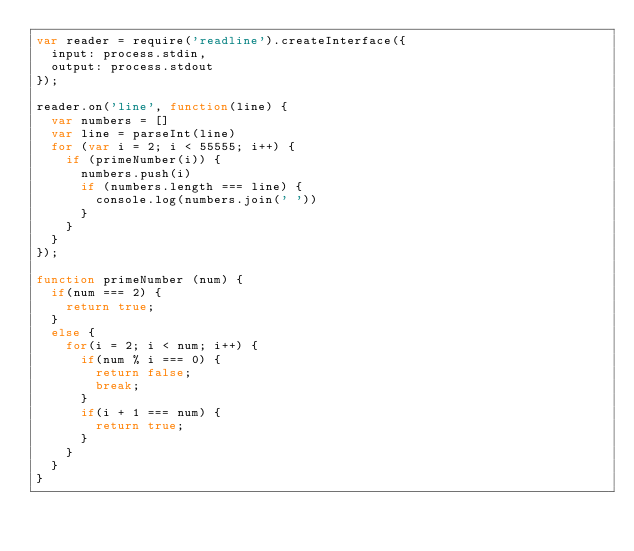<code> <loc_0><loc_0><loc_500><loc_500><_JavaScript_>var reader = require('readline').createInterface({
  input: process.stdin,
  output: process.stdout
});

reader.on('line', function(line) {
  var numbers = []
  var line = parseInt(line)
  for (var i = 2; i < 55555; i++) {
    if (primeNumber(i)) {
      numbers.push(i)
      if (numbers.length === line) {
        console.log(numbers.join(' '))
      }
    }
  }
});

function primeNumber (num) {
  if(num === 2) {
    return true;
  } 
  else {
    for(i = 2; i < num; i++) {
      if(num % i === 0) {
        return false;
        break;
      }
      if(i + 1 === num) {
        return true;
      }
    }
  }
}</code> 